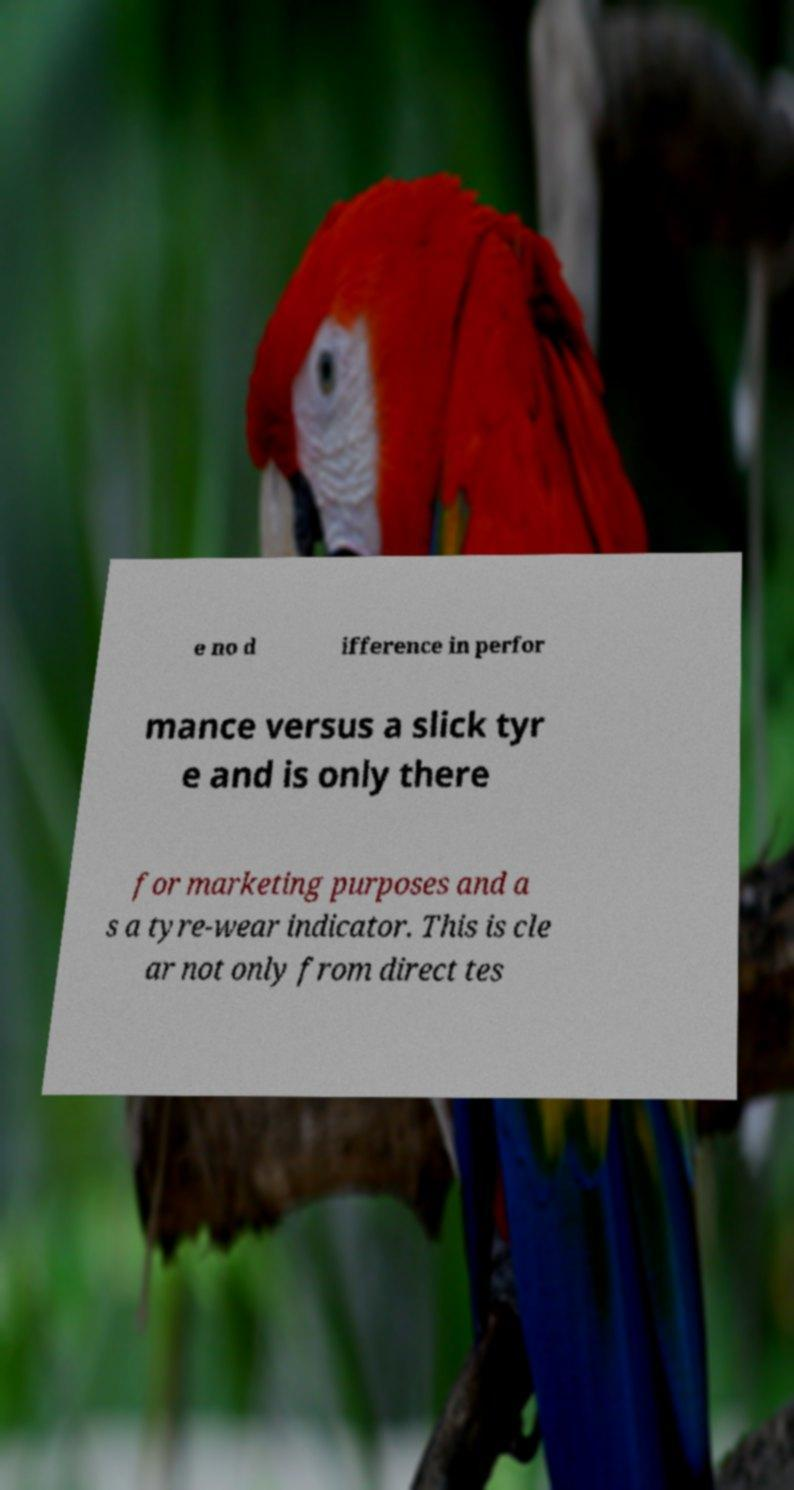There's text embedded in this image that I need extracted. Can you transcribe it verbatim? e no d ifference in perfor mance versus a slick tyr e and is only there for marketing purposes and a s a tyre-wear indicator. This is cle ar not only from direct tes 